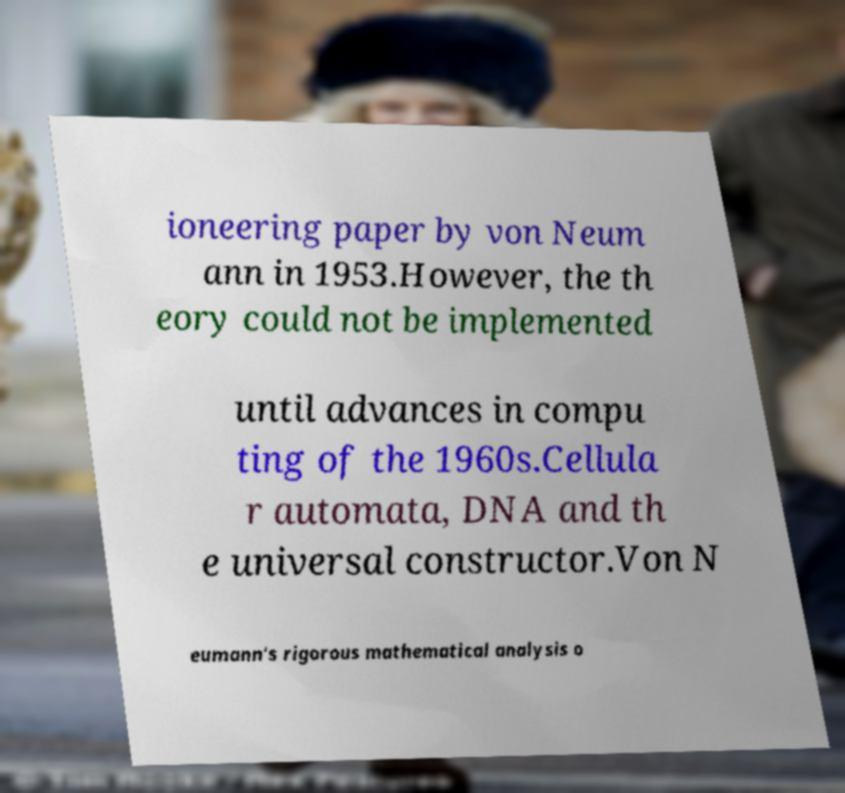Please read and relay the text visible in this image. What does it say? ioneering paper by von Neum ann in 1953.However, the th eory could not be implemented until advances in compu ting of the 1960s.Cellula r automata, DNA and th e universal constructor.Von N eumann's rigorous mathematical analysis o 